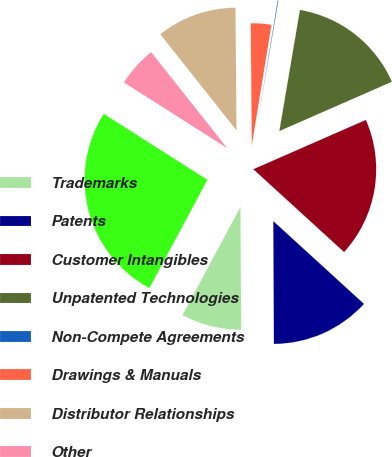Convert chart. <chart><loc_0><loc_0><loc_500><loc_500><pie_chart><fcel>Trademarks<fcel>Patents<fcel>Customer Intangibles<fcel>Unpatented Technologies<fcel>Non-Compete Agreements<fcel>Drawings & Manuals<fcel>Distributor Relationships<fcel>Other<fcel>Total<nl><fcel>7.92%<fcel>13.14%<fcel>18.35%<fcel>15.75%<fcel>0.1%<fcel>2.71%<fcel>10.53%<fcel>5.32%<fcel>26.18%<nl></chart> 